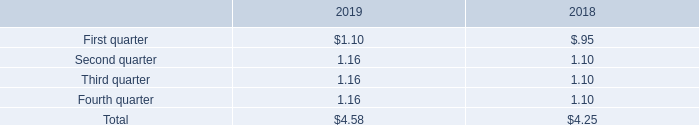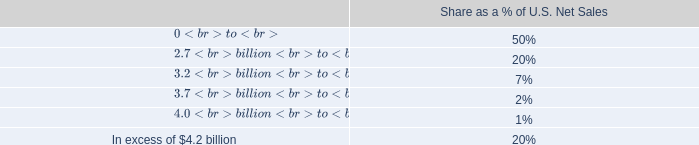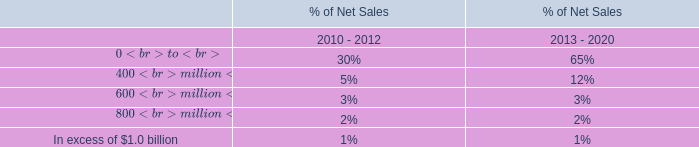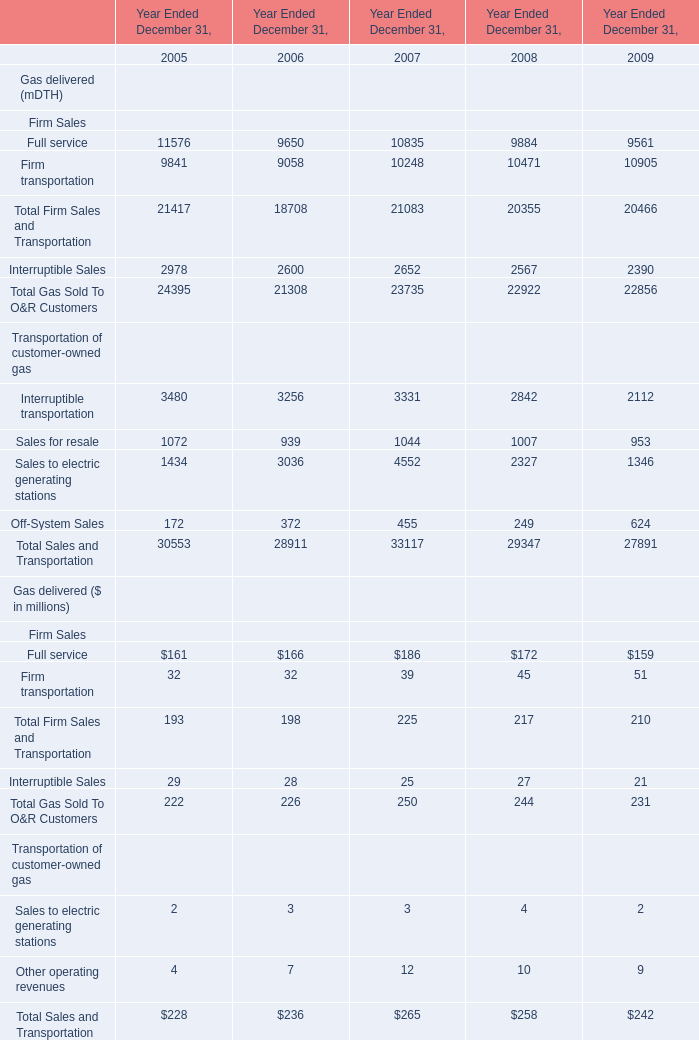What's the sum of all Firm Sales that are positive in 2005 for Gas delivered (mDTH)? (in million) 
Computations: (9841 + 11576)
Answer: 21417.0. 